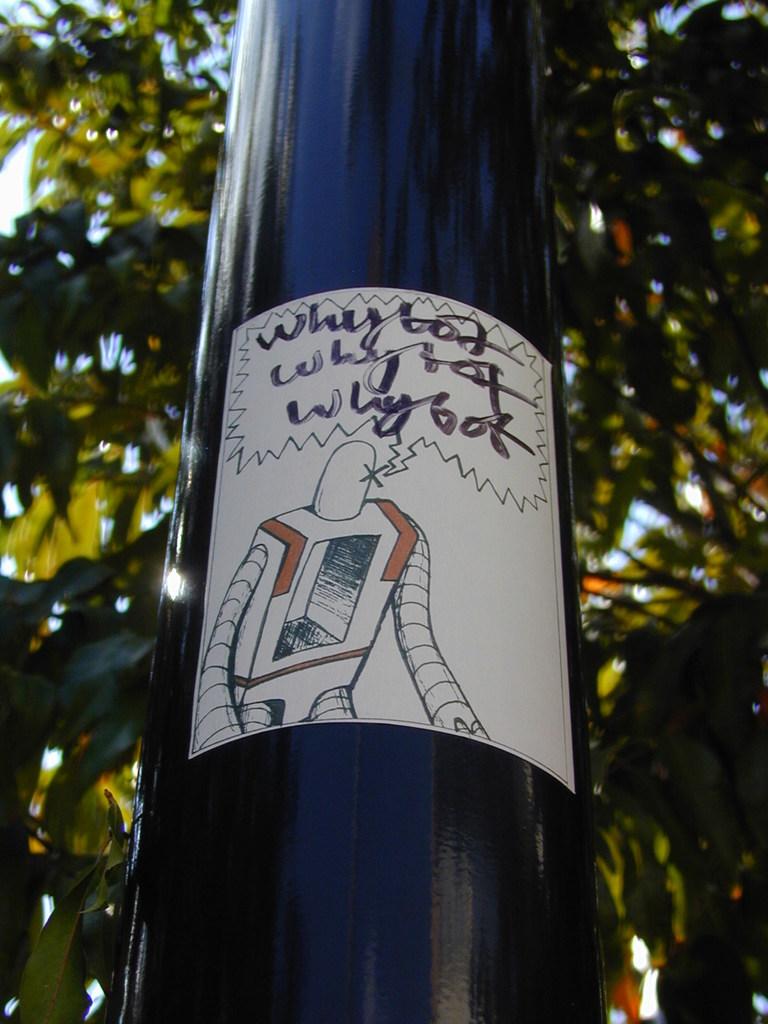What does the robot say on the bottle?
Your answer should be compact. Why bot. 